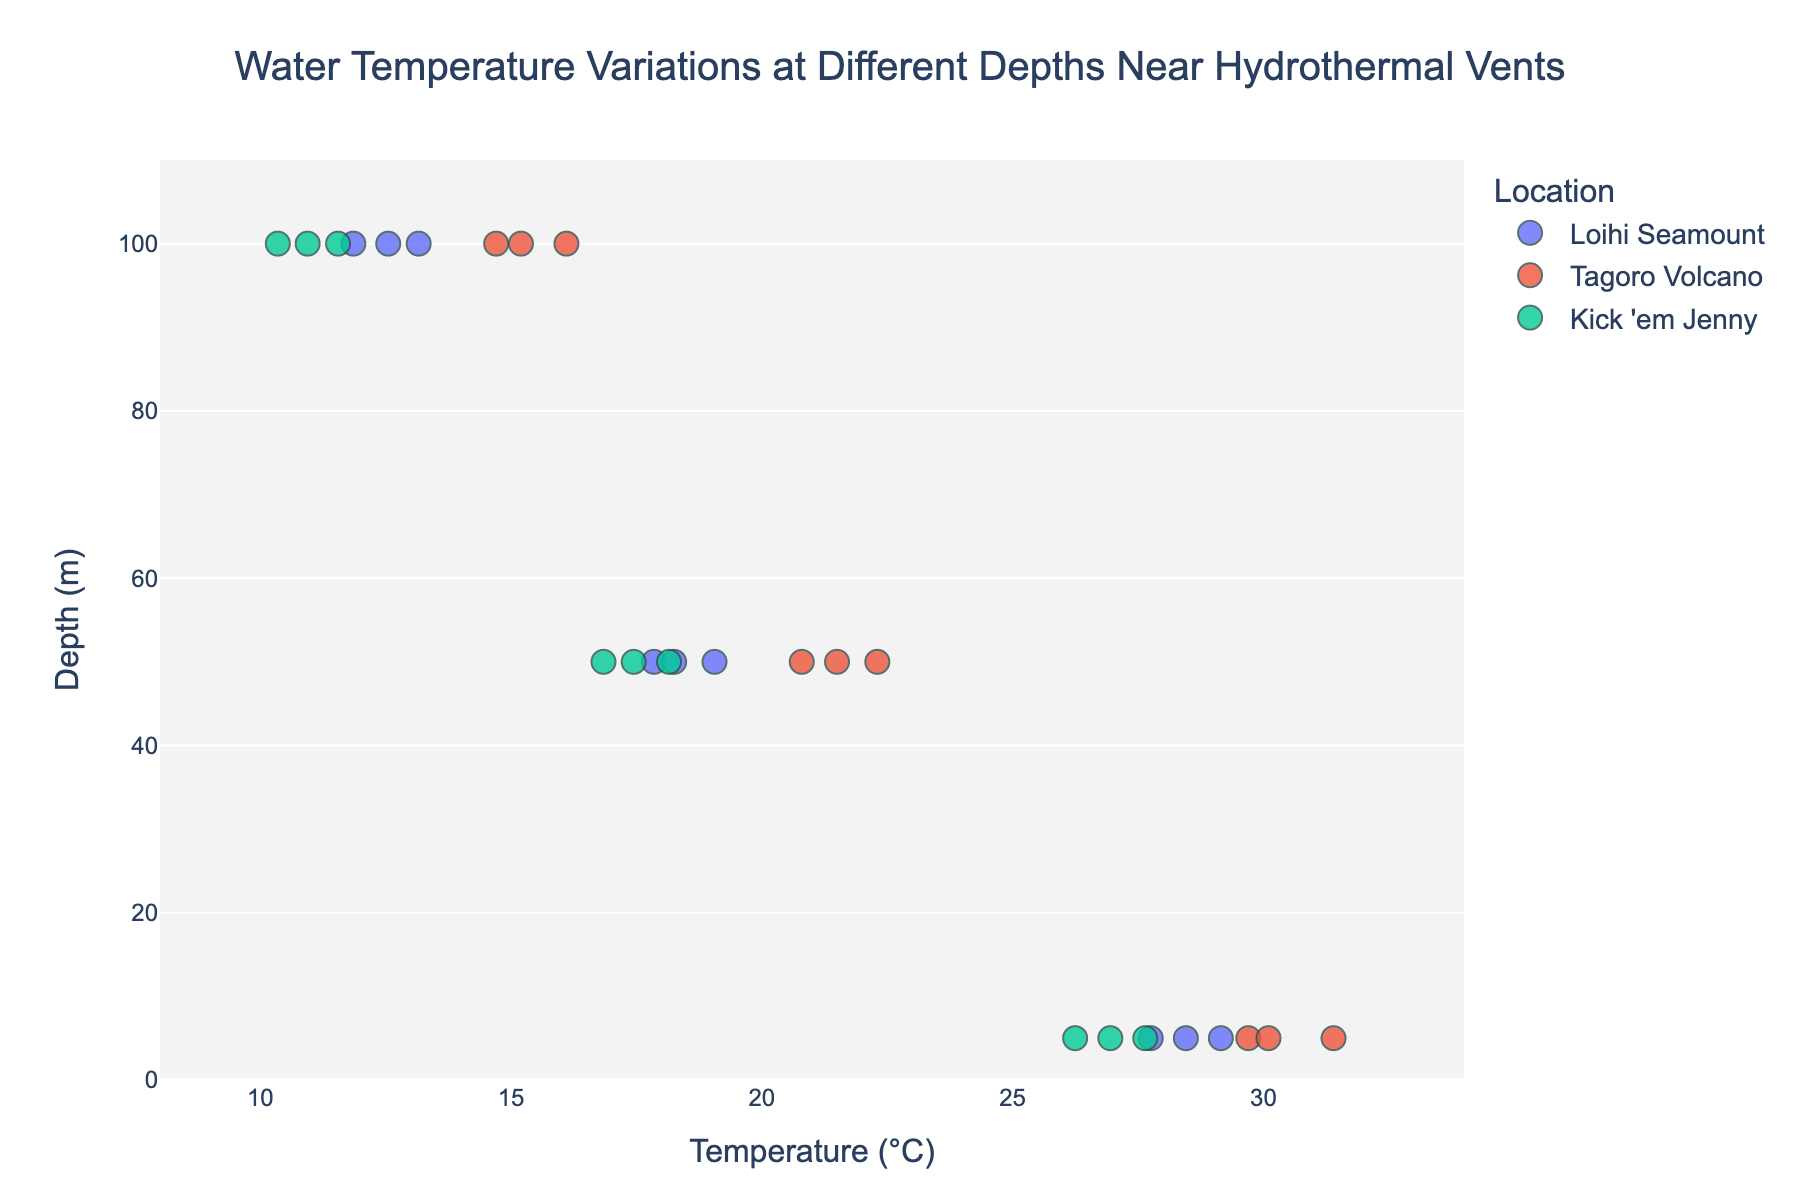What is the title of the strip plot? The title is given at the top of the plot, providing an overview of what the plot represents.
Answer: "Water Temperature Variations at Different Depths Near Hydrothermal Vents" What are the depth categories represented on the y-axis? The y-axis lists the different depths at which water temperatures were measured.
Answer: 5 m, 50 m, 100 m Which location has the highest recorded water temperature? By examining the strip plot, the highest data point can be seen. Tagoro Volcano shows the highest temperature.
Answer: Tagoro Volcano What is the range of the x-axis in the strip plot? The range can be identified by looking at the values between which the axis is scaled.
Answer: 8°C to 34°C What is the average water temperature at 50 meters depth at Loihi Seamount? At 50 meters depth at Loihi Seamount, temperatures are 18.3°C, 19.1°C, and 17.9°C. The average can be calculated as (18.3 + 19.1 + 17.9) / 3 = 18.43°C.
Answer: 18.43°C How does the temperature vary with depth at Kick 'em Jenny? By comparing the temperatures across different depths, we can observe the trend. The temperature generally decreases as depth increases at Kick 'em Jenny.
Answer: Decreases with depth Which location shows a greater temperature variation at 5 meters depth, Loihi Seamount or Tagoro Volcano? The variation can be seen by comparing the spread of data points. Tagoro Volcano has a wider range of temperatures at 5 meters compared to Loihi Seamount.
Answer: Tagoro Volcano What is the difference in the average temperature at 5 meters depth between Tagoro Volcano and Kick 'em Jenny? The average temperature at 5 meters depth for Tagoro Volcano is (30.1 + 31.4 + 29.7) / 3 = 30.4°C, and for Kick 'em Jenny it is (26.9 + 27.6 + 26.2) / 3 = 26.9°C. The difference is 30.4 - 26.9 = 3.5°C.
Answer: 3.5°C Which location has the lowest recorded water temperature at 100 meters depth? By examining the data points, we can find the lowest temperature at 100 meters. Kick 'em Jenny has the lowest recorded temperature at this depth.
Answer: Kick 'em Jenny How many data points are there for each location? By counting the number of markers, each location has 9 data points distributed among different depths.
Answer: 9 per location 